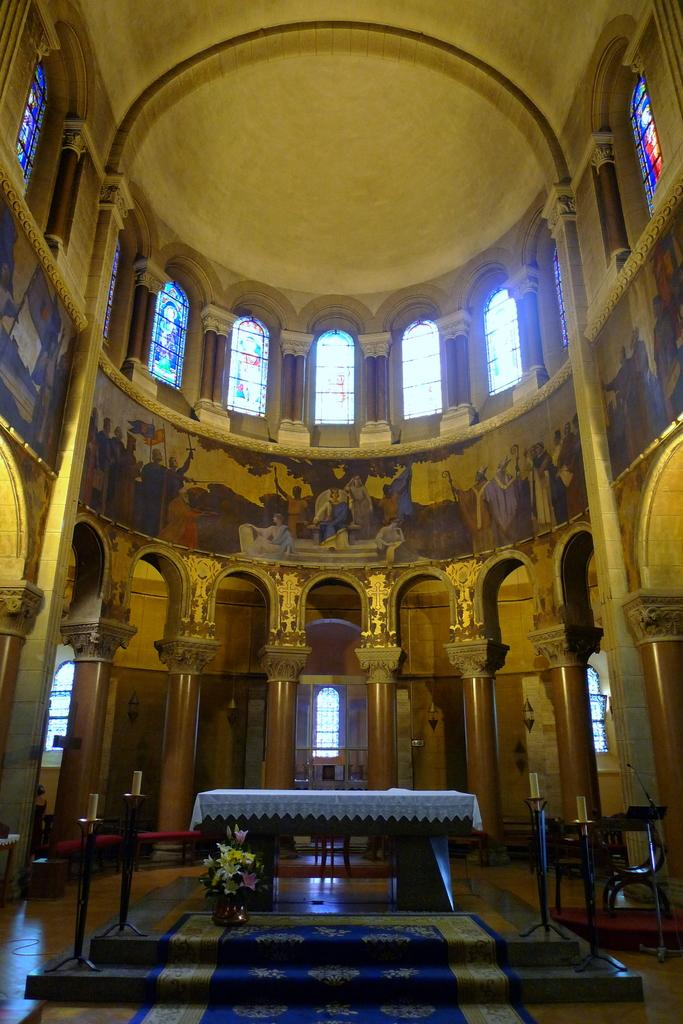What type of location is depicted in the image? The image shows an inside view of a building. What furniture piece can be seen in the image? There is a table in the image. What type of flooring is present in the image? There is a carpet in the image. What type of decorative item is present in the image? There is a flower vase in the image. What architectural feature is present in the image? There are pillars in the image. What allows natural light to enter the building in the image? There are windows in the image. What type of support structure is present in the image? There are iron stands in the image. What type of furniture is used for front in the image? There is no furniture used for front present in the image. 